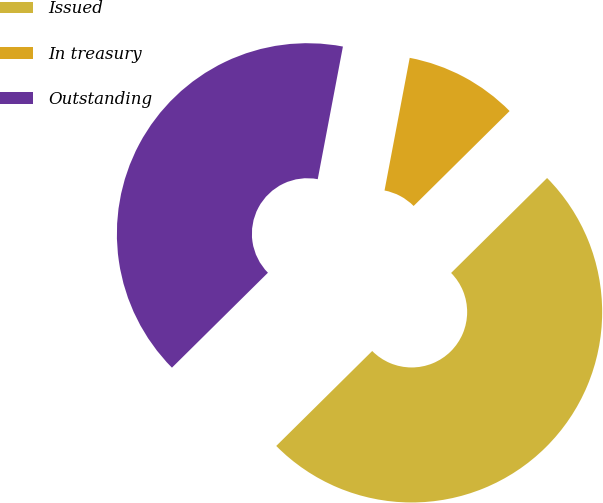Convert chart. <chart><loc_0><loc_0><loc_500><loc_500><pie_chart><fcel>Issued<fcel>In treasury<fcel>Outstanding<nl><fcel>50.0%<fcel>9.6%<fcel>40.4%<nl></chart> 